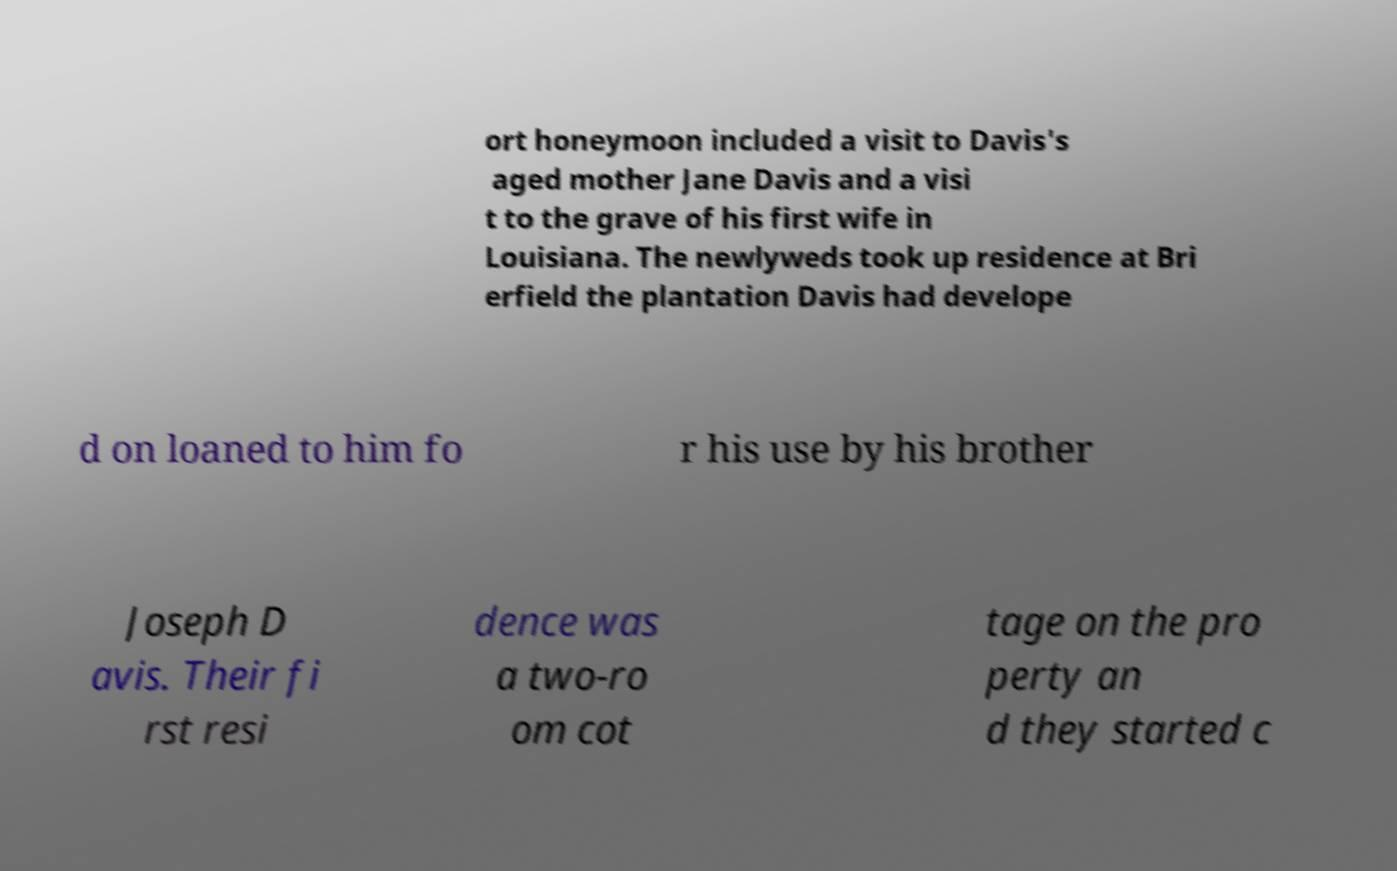For documentation purposes, I need the text within this image transcribed. Could you provide that? ort honeymoon included a visit to Davis's aged mother Jane Davis and a visi t to the grave of his first wife in Louisiana. The newlyweds took up residence at Bri erfield the plantation Davis had develope d on loaned to him fo r his use by his brother Joseph D avis. Their fi rst resi dence was a two-ro om cot tage on the pro perty an d they started c 